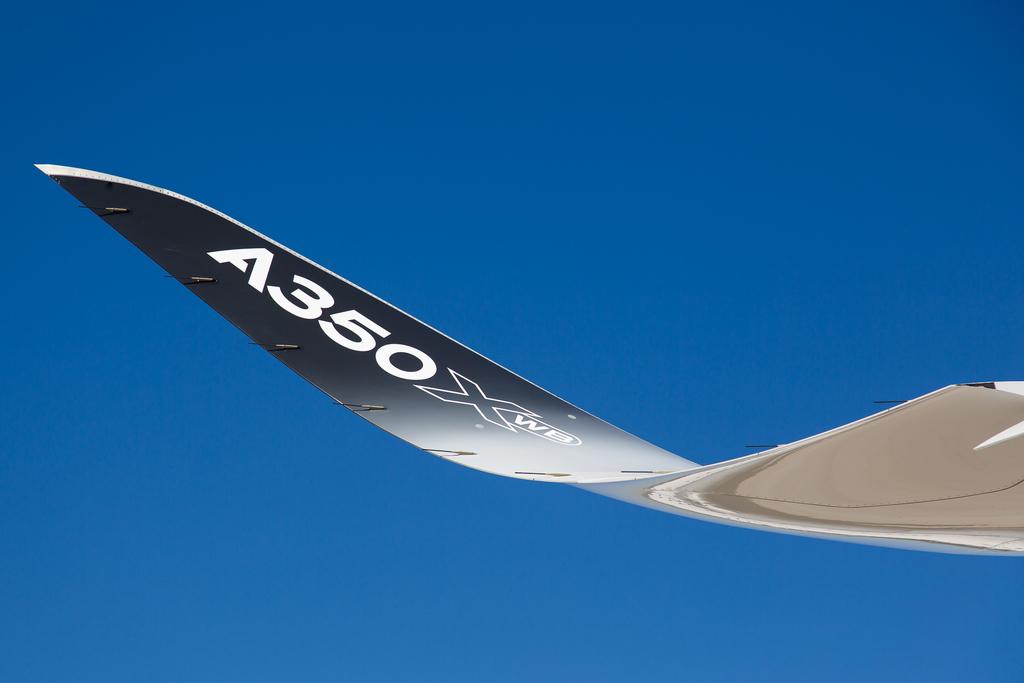What is the id number on the winf?
Your response must be concise. A350. 